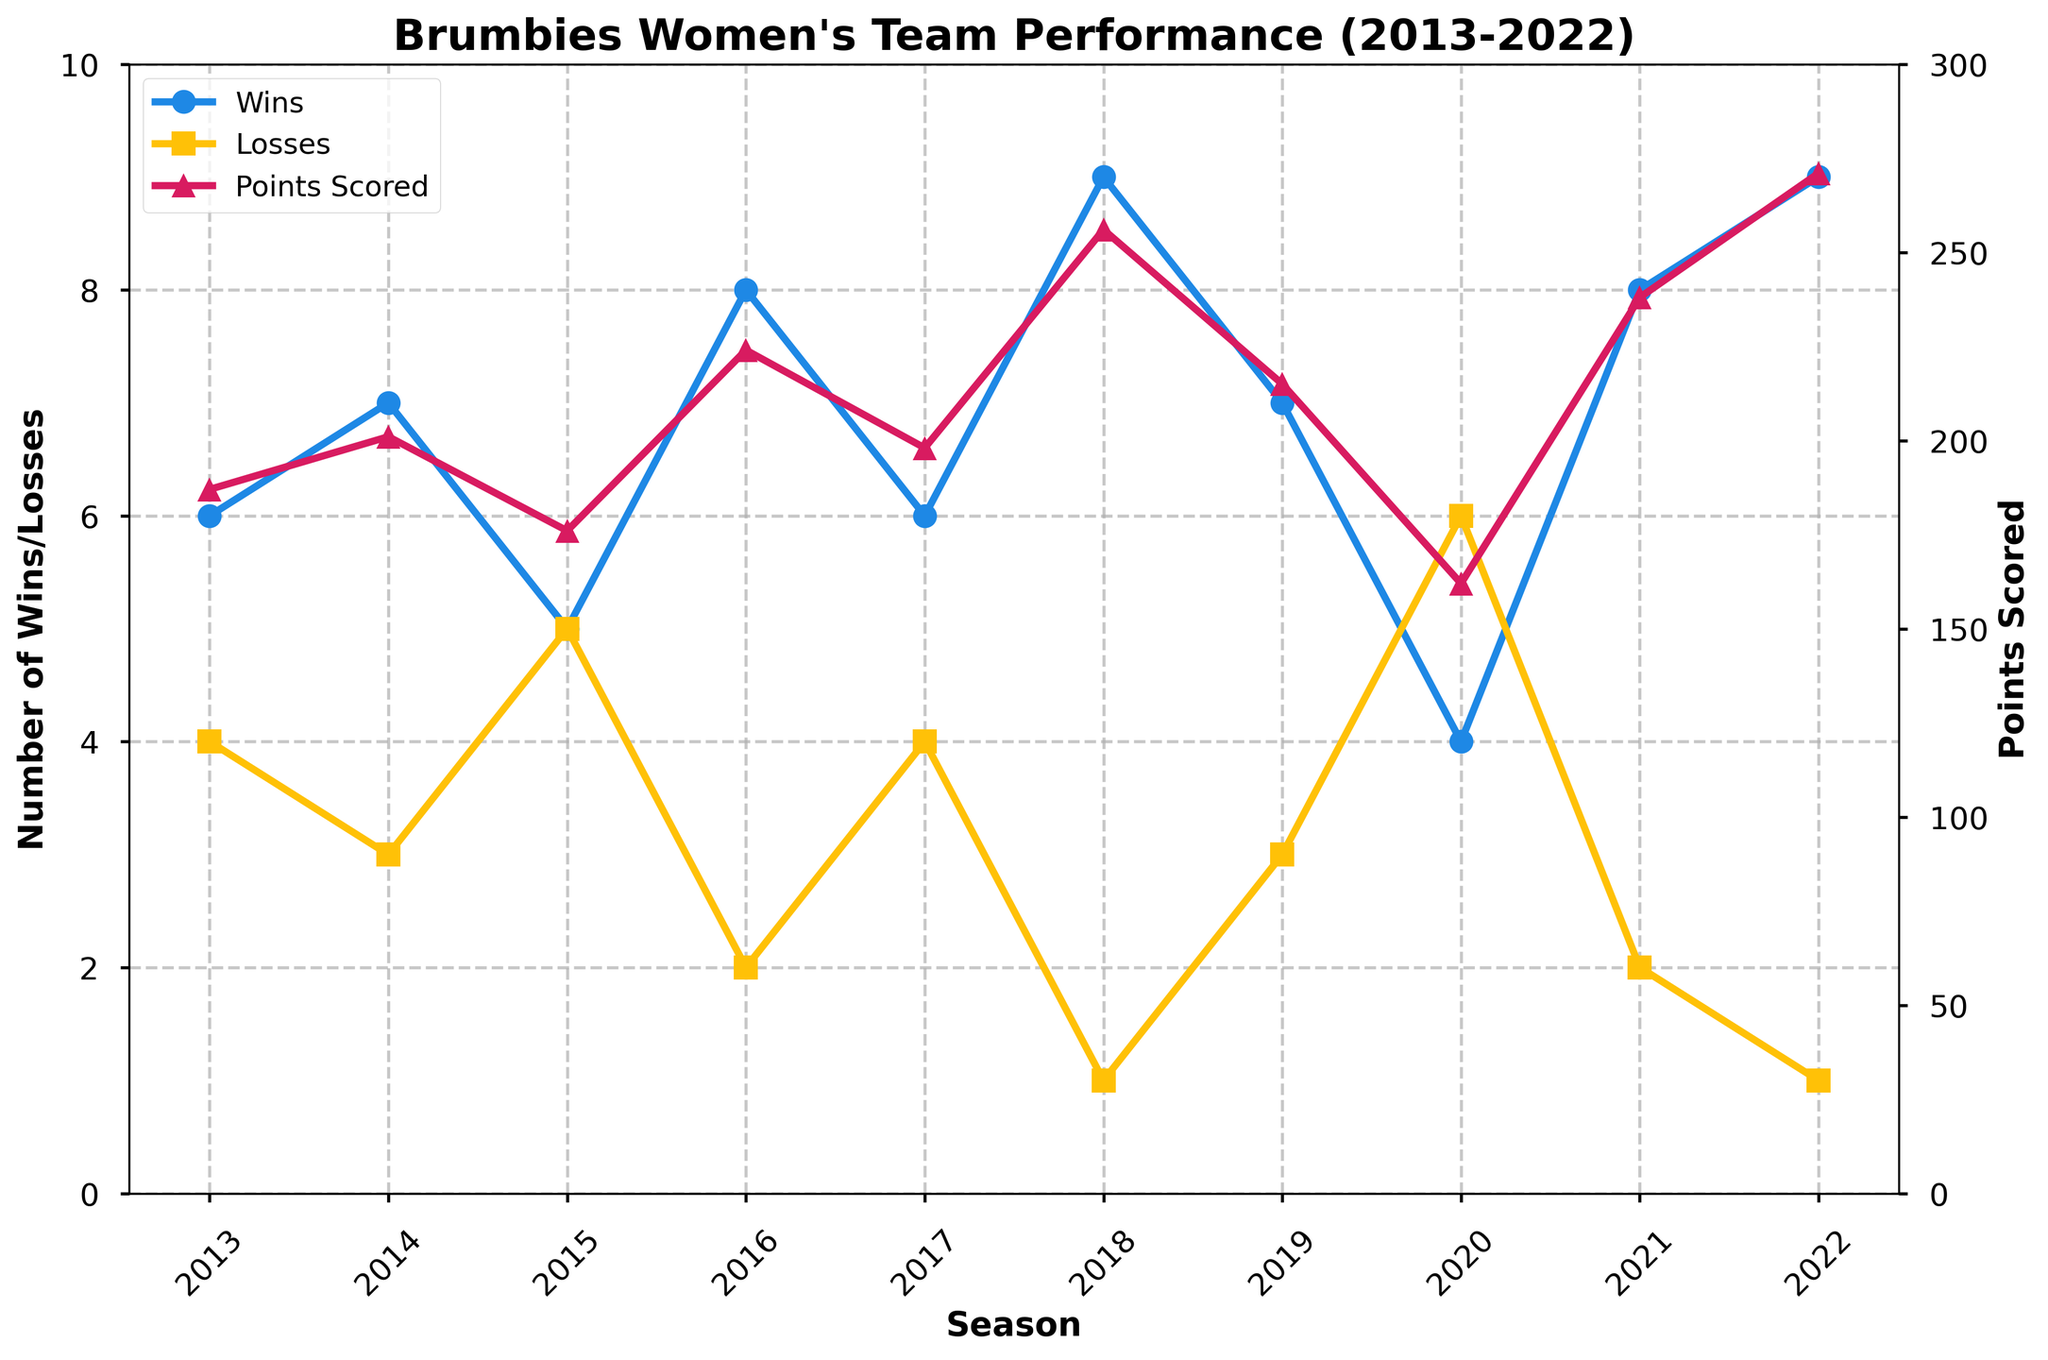How many seasons did the team have more than 7 wins? By examining the "Wins" line, we find that the team had more than 7 wins in the 2016, 2018, 2021, and 2022 seasons.
Answer: 4 In which season did the team score the highest points? The highest point on the "Points Scored" line occurs in the 2022 season, where the team scored 271 points.
Answer: 2022 What is the average number of wins across all 10 seasons? To find the average, sum all the wins (6+7+5+8+6+9+7+4+8+9 = 69) and divide by 10 seasons: 69/10 = 6.9.
Answer: 6.9 Which season had the same number of wins and losses? The number of wins equaled the number of losses in the 2015 and 2020 seasons.
Answer: 2015 and 2020 How much did the points scored increase from 2020 to 2021? From the "Points Scored" line, in 2020 the points were 162, and in 2021 they were 238. The increase is 238 - 162 = 76 points.
Answer: 76 Which season had the fewest wins? According to the "Wins" line, the fewest wins occurred in the 2020 season with 4 wins.
Answer: 2020 In which seasons did the number of wins and losses match exactly? The number of wins and losses matched in the 2015 and 2020 seasons.
Answer: 2015 and 2020 How did the team's performance in points scored change from 2014 to 2015? From the chart, in 2014 the points scored were 201, and in 2015 they were 176. The points scored decreased by 201 - 176 = 25 points.
Answer: Decreased by 25 points What is the relationship between the number of wins and points scored in the 2018 season? In 2018, the team had 9 wins and scored 256 points.
Answer: 9 wins, 256 points During which seasons did the team have the highest number of wins and the highest points scored? The highest number of wins occurred in 2018 and 2022, and the highest points scored occurred in 2022.
Answer: 2018 and 2022 